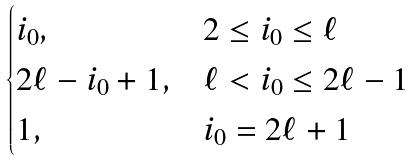Convert formula to latex. <formula><loc_0><loc_0><loc_500><loc_500>\begin{cases} i _ { 0 } , & 2 \leq i _ { 0 } \leq \ell \\ 2 \ell - i _ { 0 } + 1 , & \ell < i _ { 0 } \leq 2 \ell - 1 \\ 1 , & i _ { 0 } = 2 \ell + 1 \end{cases}</formula> 